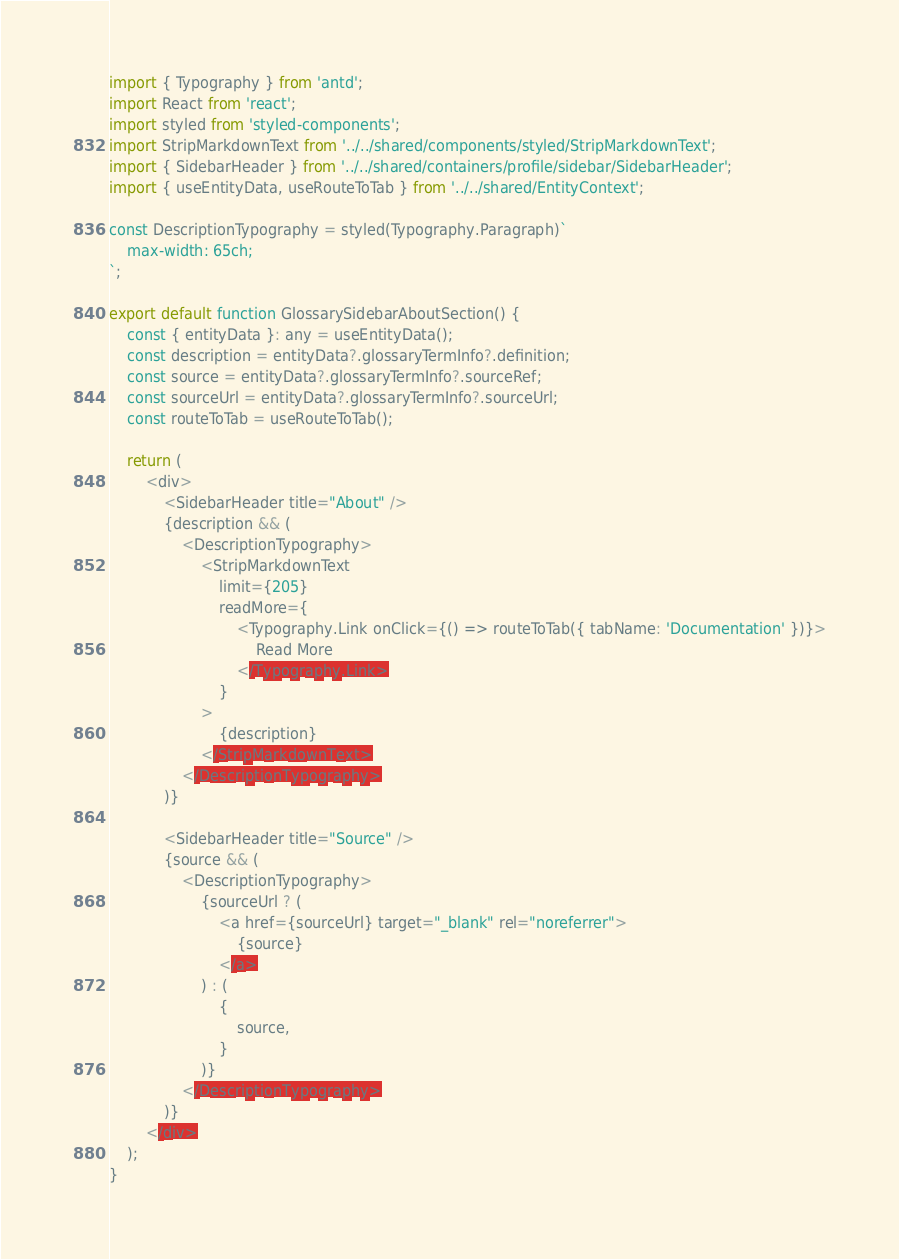<code> <loc_0><loc_0><loc_500><loc_500><_TypeScript_>import { Typography } from 'antd';
import React from 'react';
import styled from 'styled-components';
import StripMarkdownText from '../../shared/components/styled/StripMarkdownText';
import { SidebarHeader } from '../../shared/containers/profile/sidebar/SidebarHeader';
import { useEntityData, useRouteToTab } from '../../shared/EntityContext';

const DescriptionTypography = styled(Typography.Paragraph)`
    max-width: 65ch;
`;

export default function GlossarySidebarAboutSection() {
    const { entityData }: any = useEntityData();
    const description = entityData?.glossaryTermInfo?.definition;
    const source = entityData?.glossaryTermInfo?.sourceRef;
    const sourceUrl = entityData?.glossaryTermInfo?.sourceUrl;
    const routeToTab = useRouteToTab();

    return (
        <div>
            <SidebarHeader title="About" />
            {description && (
                <DescriptionTypography>
                    <StripMarkdownText
                        limit={205}
                        readMore={
                            <Typography.Link onClick={() => routeToTab({ tabName: 'Documentation' })}>
                                Read More
                            </Typography.Link>
                        }
                    >
                        {description}
                    </StripMarkdownText>
                </DescriptionTypography>
            )}

            <SidebarHeader title="Source" />
            {source && (
                <DescriptionTypography>
                    {sourceUrl ? (
                        <a href={sourceUrl} target="_blank" rel="noreferrer">
                            {source}
                        </a>
                    ) : (
                        {
                            source,
                        }
                    )}
                </DescriptionTypography>
            )}
        </div>
    );
}
</code> 